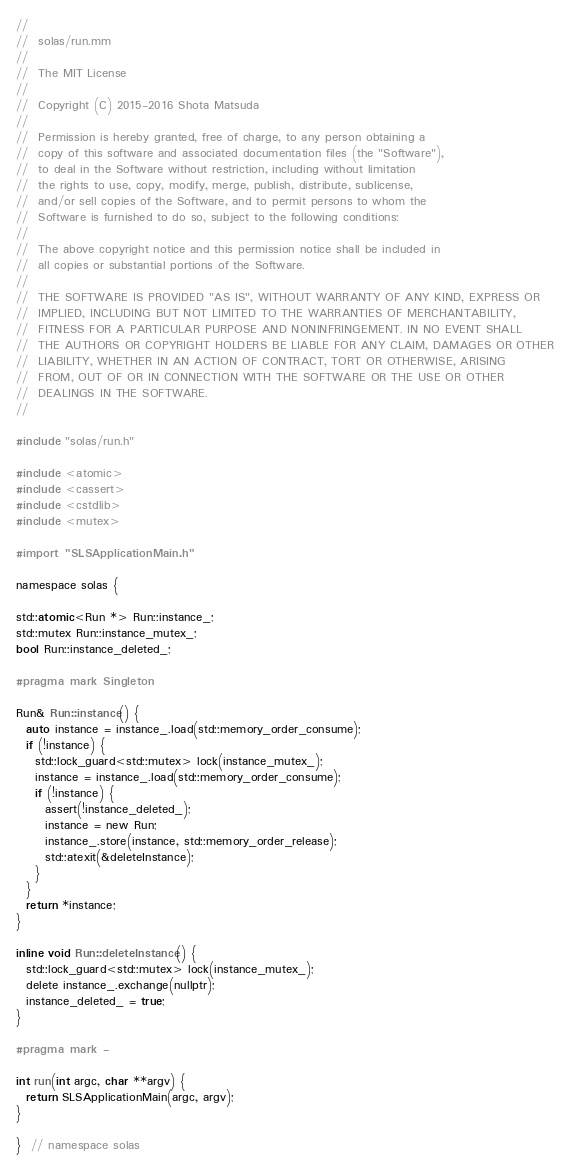Convert code to text. <code><loc_0><loc_0><loc_500><loc_500><_ObjectiveC_>//
//  solas/run.mm
//
//  The MIT License
//
//  Copyright (C) 2015-2016 Shota Matsuda
//
//  Permission is hereby granted, free of charge, to any person obtaining a
//  copy of this software and associated documentation files (the "Software"),
//  to deal in the Software without restriction, including without limitation
//  the rights to use, copy, modify, merge, publish, distribute, sublicense,
//  and/or sell copies of the Software, and to permit persons to whom the
//  Software is furnished to do so, subject to the following conditions:
//
//  The above copyright notice and this permission notice shall be included in
//  all copies or substantial portions of the Software.
//
//  THE SOFTWARE IS PROVIDED "AS IS", WITHOUT WARRANTY OF ANY KIND, EXPRESS OR
//  IMPLIED, INCLUDING BUT NOT LIMITED TO THE WARRANTIES OF MERCHANTABILITY,
//  FITNESS FOR A PARTICULAR PURPOSE AND NONINFRINGEMENT. IN NO EVENT SHALL
//  THE AUTHORS OR COPYRIGHT HOLDERS BE LIABLE FOR ANY CLAIM, DAMAGES OR OTHER
//  LIABILITY, WHETHER IN AN ACTION OF CONTRACT, TORT OR OTHERWISE, ARISING
//  FROM, OUT OF OR IN CONNECTION WITH THE SOFTWARE OR THE USE OR OTHER
//  DEALINGS IN THE SOFTWARE.
//

#include "solas/run.h"

#include <atomic>
#include <cassert>
#include <cstdlib>
#include <mutex>

#import "SLSApplicationMain.h"

namespace solas {

std::atomic<Run *> Run::instance_;
std::mutex Run::instance_mutex_;
bool Run::instance_deleted_;

#pragma mark Singleton

Run& Run::instance() {
  auto instance = instance_.load(std::memory_order_consume);
  if (!instance) {
    std::lock_guard<std::mutex> lock(instance_mutex_);
    instance = instance_.load(std::memory_order_consume);
    if (!instance) {
      assert(!instance_deleted_);
      instance = new Run;
      instance_.store(instance, std::memory_order_release);
      std::atexit(&deleteInstance);
    }
  }
  return *instance;
}

inline void Run::deleteInstance() {
  std::lock_guard<std::mutex> lock(instance_mutex_);
  delete instance_.exchange(nullptr);
  instance_deleted_ = true;
}

#pragma mark -

int run(int argc, char **argv) {
  return SLSApplicationMain(argc, argv);
}

}  // namespace solas
</code> 